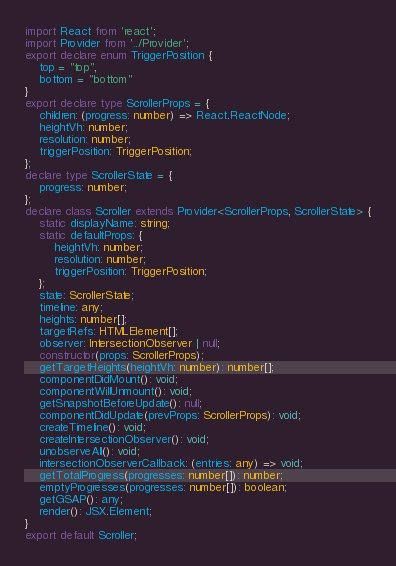Convert code to text. <code><loc_0><loc_0><loc_500><loc_500><_TypeScript_>import React from 'react';
import Provider from '../Provider';
export declare enum TriggerPosition {
    top = "top",
    bottom = "bottom"
}
export declare type ScrollerProps = {
    children: (progress: number) => React.ReactNode;
    heightVh: number;
    resolution: number;
    triggerPosition: TriggerPosition;
};
declare type ScrollerState = {
    progress: number;
};
declare class Scroller extends Provider<ScrollerProps, ScrollerState> {
    static displayName: string;
    static defaultProps: {
        heightVh: number;
        resolution: number;
        triggerPosition: TriggerPosition;
    };
    state: ScrollerState;
    timeline: any;
    heights: number[];
    targetRefs: HTMLElement[];
    observer: IntersectionObserver | null;
    constructor(props: ScrollerProps);
    getTargetHeights(heightVh: number): number[];
    componentDidMount(): void;
    componentWillUnmount(): void;
    getSnapshotBeforeUpdate(): null;
    componentDidUpdate(prevProps: ScrollerProps): void;
    createTimeline(): void;
    createIntersectionObserver(): void;
    unobserveAll(): void;
    intersectionObserverCallback: (entries: any) => void;
    getTotalProgress(progresses: number[]): number;
    emptyProgresses(progresses: number[]): boolean;
    getGSAP(): any;
    render(): JSX.Element;
}
export default Scroller;
</code> 